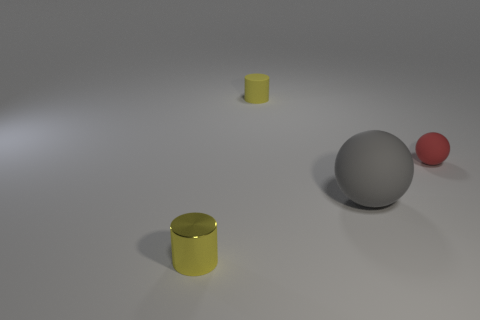Is the number of tiny metal cylinders that are behind the small red rubber object less than the number of big yellow matte objects?
Your answer should be very brief. No. Are there fewer yellow metallic cylinders that are to the right of the tiny red rubber object than small balls to the left of the yellow matte cylinder?
Your response must be concise. No. How many cylinders are large gray things or small yellow things?
Make the answer very short. 2. Is the material of the object that is behind the tiny rubber sphere the same as the ball on the left side of the tiny red rubber ball?
Make the answer very short. Yes. The yellow matte thing that is the same size as the yellow shiny cylinder is what shape?
Provide a short and direct response. Cylinder. What number of other things are the same color as the metallic thing?
Make the answer very short. 1. How many yellow things are either metal cylinders or small matte balls?
Your response must be concise. 1. There is a yellow thing that is left of the matte cylinder; is its shape the same as the rubber thing that is to the left of the big thing?
Keep it short and to the point. Yes. How many other objects are the same material as the small sphere?
Your answer should be compact. 2. Is there a large gray rubber sphere in front of the tiny yellow object in front of the small thing that is right of the matte cylinder?
Make the answer very short. No. 